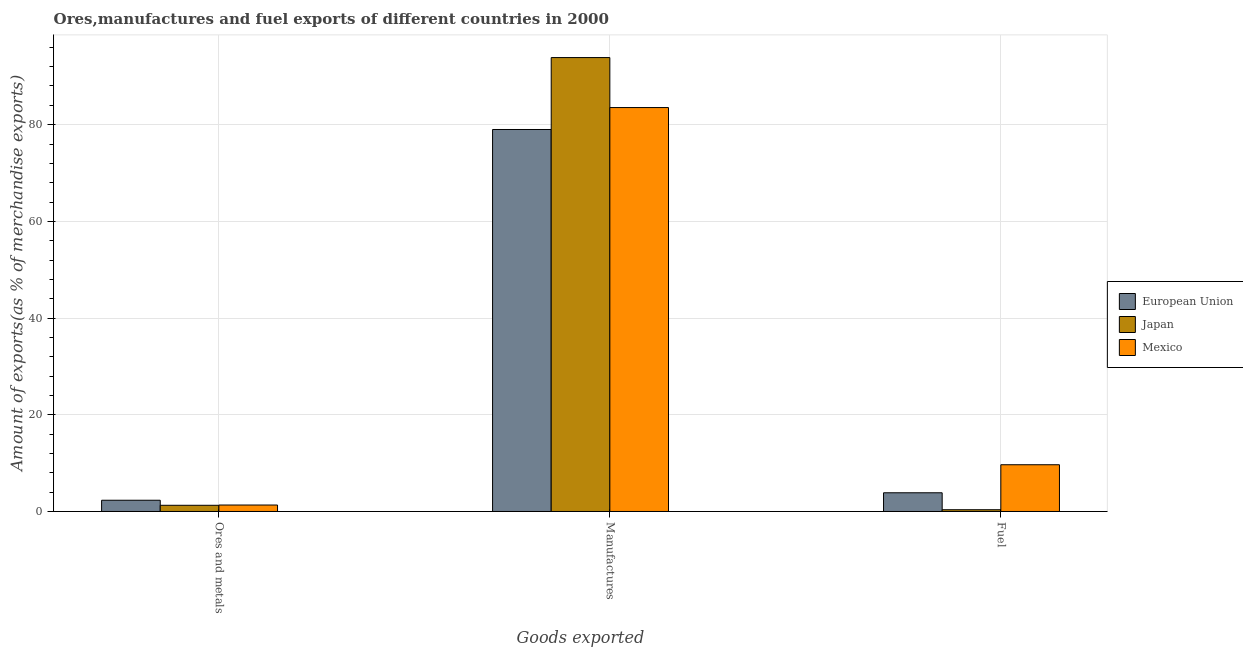Are the number of bars on each tick of the X-axis equal?
Make the answer very short. Yes. How many bars are there on the 2nd tick from the left?
Give a very brief answer. 3. How many bars are there on the 2nd tick from the right?
Your answer should be compact. 3. What is the label of the 1st group of bars from the left?
Your answer should be very brief. Ores and metals. What is the percentage of manufactures exports in Mexico?
Offer a very short reply. 83.54. Across all countries, what is the maximum percentage of manufactures exports?
Your answer should be very brief. 93.88. Across all countries, what is the minimum percentage of manufactures exports?
Give a very brief answer. 79. In which country was the percentage of fuel exports maximum?
Give a very brief answer. Mexico. In which country was the percentage of fuel exports minimum?
Your answer should be very brief. Japan. What is the total percentage of fuel exports in the graph?
Make the answer very short. 13.9. What is the difference between the percentage of fuel exports in Japan and that in European Union?
Give a very brief answer. -3.51. What is the difference between the percentage of manufactures exports in Mexico and the percentage of ores and metals exports in European Union?
Provide a succinct answer. 81.21. What is the average percentage of fuel exports per country?
Make the answer very short. 4.63. What is the difference between the percentage of fuel exports and percentage of ores and metals exports in Mexico?
Ensure brevity in your answer.  8.33. In how many countries, is the percentage of fuel exports greater than 8 %?
Ensure brevity in your answer.  1. What is the ratio of the percentage of ores and metals exports in Mexico to that in European Union?
Keep it short and to the point. 0.57. Is the percentage of manufactures exports in Japan less than that in European Union?
Offer a terse response. No. What is the difference between the highest and the second highest percentage of ores and metals exports?
Offer a very short reply. 0.99. What is the difference between the highest and the lowest percentage of fuel exports?
Give a very brief answer. 9.3. What does the 3rd bar from the right in Fuel represents?
Your answer should be very brief. European Union. Is it the case that in every country, the sum of the percentage of ores and metals exports and percentage of manufactures exports is greater than the percentage of fuel exports?
Provide a succinct answer. Yes. How many bars are there?
Make the answer very short. 9. Are the values on the major ticks of Y-axis written in scientific E-notation?
Your answer should be very brief. No. Does the graph contain grids?
Your answer should be very brief. Yes. How are the legend labels stacked?
Your answer should be very brief. Vertical. What is the title of the graph?
Offer a terse response. Ores,manufactures and fuel exports of different countries in 2000. What is the label or title of the X-axis?
Offer a very short reply. Goods exported. What is the label or title of the Y-axis?
Provide a succinct answer. Amount of exports(as % of merchandise exports). What is the Amount of exports(as % of merchandise exports) in European Union in Ores and metals?
Your answer should be compact. 2.33. What is the Amount of exports(as % of merchandise exports) in Japan in Ores and metals?
Offer a terse response. 1.28. What is the Amount of exports(as % of merchandise exports) of Mexico in Ores and metals?
Your answer should be compact. 1.33. What is the Amount of exports(as % of merchandise exports) of European Union in Manufactures?
Make the answer very short. 79. What is the Amount of exports(as % of merchandise exports) of Japan in Manufactures?
Provide a short and direct response. 93.88. What is the Amount of exports(as % of merchandise exports) of Mexico in Manufactures?
Give a very brief answer. 83.54. What is the Amount of exports(as % of merchandise exports) of European Union in Fuel?
Provide a short and direct response. 3.87. What is the Amount of exports(as % of merchandise exports) of Japan in Fuel?
Offer a very short reply. 0.36. What is the Amount of exports(as % of merchandise exports) of Mexico in Fuel?
Provide a succinct answer. 9.67. Across all Goods exported, what is the maximum Amount of exports(as % of merchandise exports) in European Union?
Offer a very short reply. 79. Across all Goods exported, what is the maximum Amount of exports(as % of merchandise exports) of Japan?
Your answer should be very brief. 93.88. Across all Goods exported, what is the maximum Amount of exports(as % of merchandise exports) of Mexico?
Keep it short and to the point. 83.54. Across all Goods exported, what is the minimum Amount of exports(as % of merchandise exports) in European Union?
Your answer should be very brief. 2.33. Across all Goods exported, what is the minimum Amount of exports(as % of merchandise exports) in Japan?
Make the answer very short. 0.36. Across all Goods exported, what is the minimum Amount of exports(as % of merchandise exports) of Mexico?
Offer a terse response. 1.33. What is the total Amount of exports(as % of merchandise exports) in European Union in the graph?
Your response must be concise. 85.2. What is the total Amount of exports(as % of merchandise exports) of Japan in the graph?
Your answer should be very brief. 95.52. What is the total Amount of exports(as % of merchandise exports) in Mexico in the graph?
Keep it short and to the point. 94.54. What is the difference between the Amount of exports(as % of merchandise exports) in European Union in Ores and metals and that in Manufactures?
Give a very brief answer. -76.68. What is the difference between the Amount of exports(as % of merchandise exports) in Japan in Ores and metals and that in Manufactures?
Offer a very short reply. -92.59. What is the difference between the Amount of exports(as % of merchandise exports) in Mexico in Ores and metals and that in Manufactures?
Your answer should be very brief. -82.2. What is the difference between the Amount of exports(as % of merchandise exports) of European Union in Ores and metals and that in Fuel?
Provide a short and direct response. -1.54. What is the difference between the Amount of exports(as % of merchandise exports) in Japan in Ores and metals and that in Fuel?
Provide a succinct answer. 0.92. What is the difference between the Amount of exports(as % of merchandise exports) of Mexico in Ores and metals and that in Fuel?
Offer a very short reply. -8.33. What is the difference between the Amount of exports(as % of merchandise exports) in European Union in Manufactures and that in Fuel?
Make the answer very short. 75.13. What is the difference between the Amount of exports(as % of merchandise exports) of Japan in Manufactures and that in Fuel?
Make the answer very short. 93.51. What is the difference between the Amount of exports(as % of merchandise exports) in Mexico in Manufactures and that in Fuel?
Your answer should be compact. 73.87. What is the difference between the Amount of exports(as % of merchandise exports) of European Union in Ores and metals and the Amount of exports(as % of merchandise exports) of Japan in Manufactures?
Provide a short and direct response. -91.55. What is the difference between the Amount of exports(as % of merchandise exports) of European Union in Ores and metals and the Amount of exports(as % of merchandise exports) of Mexico in Manufactures?
Offer a very short reply. -81.21. What is the difference between the Amount of exports(as % of merchandise exports) of Japan in Ores and metals and the Amount of exports(as % of merchandise exports) of Mexico in Manufactures?
Your answer should be compact. -82.26. What is the difference between the Amount of exports(as % of merchandise exports) in European Union in Ores and metals and the Amount of exports(as % of merchandise exports) in Japan in Fuel?
Your answer should be compact. 1.96. What is the difference between the Amount of exports(as % of merchandise exports) of European Union in Ores and metals and the Amount of exports(as % of merchandise exports) of Mexico in Fuel?
Your answer should be very brief. -7.34. What is the difference between the Amount of exports(as % of merchandise exports) in Japan in Ores and metals and the Amount of exports(as % of merchandise exports) in Mexico in Fuel?
Keep it short and to the point. -8.38. What is the difference between the Amount of exports(as % of merchandise exports) in European Union in Manufactures and the Amount of exports(as % of merchandise exports) in Japan in Fuel?
Your answer should be compact. 78.64. What is the difference between the Amount of exports(as % of merchandise exports) in European Union in Manufactures and the Amount of exports(as % of merchandise exports) in Mexico in Fuel?
Your answer should be compact. 69.33. What is the difference between the Amount of exports(as % of merchandise exports) in Japan in Manufactures and the Amount of exports(as % of merchandise exports) in Mexico in Fuel?
Your answer should be compact. 84.21. What is the average Amount of exports(as % of merchandise exports) in European Union per Goods exported?
Give a very brief answer. 28.4. What is the average Amount of exports(as % of merchandise exports) in Japan per Goods exported?
Make the answer very short. 31.84. What is the average Amount of exports(as % of merchandise exports) in Mexico per Goods exported?
Keep it short and to the point. 31.51. What is the difference between the Amount of exports(as % of merchandise exports) in European Union and Amount of exports(as % of merchandise exports) in Japan in Ores and metals?
Provide a short and direct response. 1.04. What is the difference between the Amount of exports(as % of merchandise exports) in Japan and Amount of exports(as % of merchandise exports) in Mexico in Ores and metals?
Keep it short and to the point. -0.05. What is the difference between the Amount of exports(as % of merchandise exports) of European Union and Amount of exports(as % of merchandise exports) of Japan in Manufactures?
Your answer should be very brief. -14.88. What is the difference between the Amount of exports(as % of merchandise exports) of European Union and Amount of exports(as % of merchandise exports) of Mexico in Manufactures?
Keep it short and to the point. -4.54. What is the difference between the Amount of exports(as % of merchandise exports) of Japan and Amount of exports(as % of merchandise exports) of Mexico in Manufactures?
Your response must be concise. 10.34. What is the difference between the Amount of exports(as % of merchandise exports) of European Union and Amount of exports(as % of merchandise exports) of Japan in Fuel?
Make the answer very short. 3.51. What is the difference between the Amount of exports(as % of merchandise exports) of European Union and Amount of exports(as % of merchandise exports) of Mexico in Fuel?
Give a very brief answer. -5.8. What is the difference between the Amount of exports(as % of merchandise exports) in Japan and Amount of exports(as % of merchandise exports) in Mexico in Fuel?
Provide a short and direct response. -9.3. What is the ratio of the Amount of exports(as % of merchandise exports) in European Union in Ores and metals to that in Manufactures?
Keep it short and to the point. 0.03. What is the ratio of the Amount of exports(as % of merchandise exports) of Japan in Ores and metals to that in Manufactures?
Your answer should be compact. 0.01. What is the ratio of the Amount of exports(as % of merchandise exports) of Mexico in Ores and metals to that in Manufactures?
Ensure brevity in your answer.  0.02. What is the ratio of the Amount of exports(as % of merchandise exports) of European Union in Ores and metals to that in Fuel?
Offer a very short reply. 0.6. What is the ratio of the Amount of exports(as % of merchandise exports) of Japan in Ores and metals to that in Fuel?
Offer a terse response. 3.53. What is the ratio of the Amount of exports(as % of merchandise exports) in Mexico in Ores and metals to that in Fuel?
Offer a very short reply. 0.14. What is the ratio of the Amount of exports(as % of merchandise exports) of European Union in Manufactures to that in Fuel?
Your answer should be very brief. 20.42. What is the ratio of the Amount of exports(as % of merchandise exports) in Japan in Manufactures to that in Fuel?
Provide a succinct answer. 258.46. What is the ratio of the Amount of exports(as % of merchandise exports) of Mexico in Manufactures to that in Fuel?
Make the answer very short. 8.64. What is the difference between the highest and the second highest Amount of exports(as % of merchandise exports) of European Union?
Provide a short and direct response. 75.13. What is the difference between the highest and the second highest Amount of exports(as % of merchandise exports) of Japan?
Ensure brevity in your answer.  92.59. What is the difference between the highest and the second highest Amount of exports(as % of merchandise exports) in Mexico?
Provide a short and direct response. 73.87. What is the difference between the highest and the lowest Amount of exports(as % of merchandise exports) of European Union?
Provide a succinct answer. 76.68. What is the difference between the highest and the lowest Amount of exports(as % of merchandise exports) in Japan?
Give a very brief answer. 93.51. What is the difference between the highest and the lowest Amount of exports(as % of merchandise exports) in Mexico?
Your answer should be compact. 82.2. 